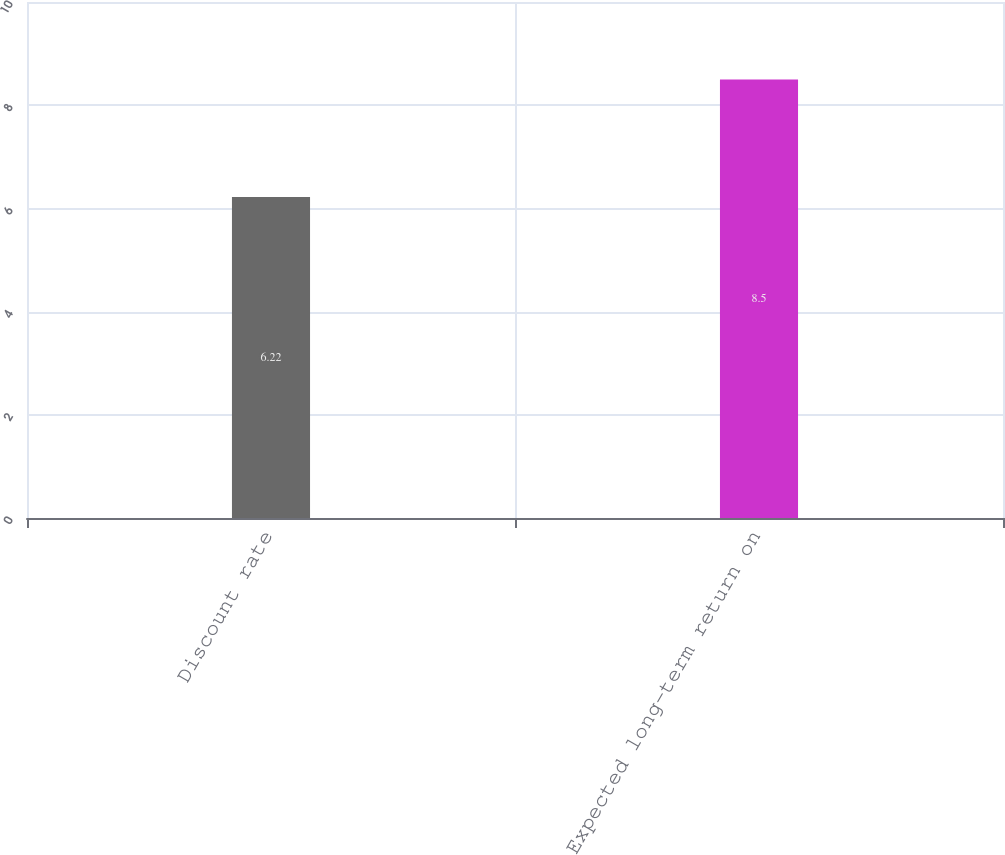<chart> <loc_0><loc_0><loc_500><loc_500><bar_chart><fcel>Discount rate<fcel>Expected long-term return on<nl><fcel>6.22<fcel>8.5<nl></chart> 